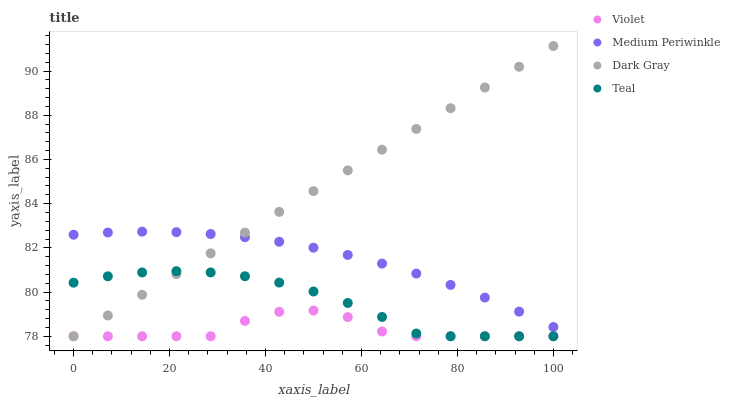Does Violet have the minimum area under the curve?
Answer yes or no. Yes. Does Dark Gray have the maximum area under the curve?
Answer yes or no. Yes. Does Medium Periwinkle have the minimum area under the curve?
Answer yes or no. No. Does Medium Periwinkle have the maximum area under the curve?
Answer yes or no. No. Is Dark Gray the smoothest?
Answer yes or no. Yes. Is Violet the roughest?
Answer yes or no. Yes. Is Medium Periwinkle the smoothest?
Answer yes or no. No. Is Medium Periwinkle the roughest?
Answer yes or no. No. Does Dark Gray have the lowest value?
Answer yes or no. Yes. Does Medium Periwinkle have the lowest value?
Answer yes or no. No. Does Dark Gray have the highest value?
Answer yes or no. Yes. Does Medium Periwinkle have the highest value?
Answer yes or no. No. Is Violet less than Medium Periwinkle?
Answer yes or no. Yes. Is Medium Periwinkle greater than Violet?
Answer yes or no. Yes. Does Dark Gray intersect Medium Periwinkle?
Answer yes or no. Yes. Is Dark Gray less than Medium Periwinkle?
Answer yes or no. No. Is Dark Gray greater than Medium Periwinkle?
Answer yes or no. No. Does Violet intersect Medium Periwinkle?
Answer yes or no. No. 